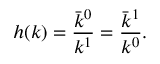Convert formula to latex. <formula><loc_0><loc_0><loc_500><loc_500>h ( k ) = \frac { \bar { k } ^ { 0 } } { k ^ { 1 } } = \frac { \bar { k } ^ { 1 } } { k ^ { 0 } } .</formula> 